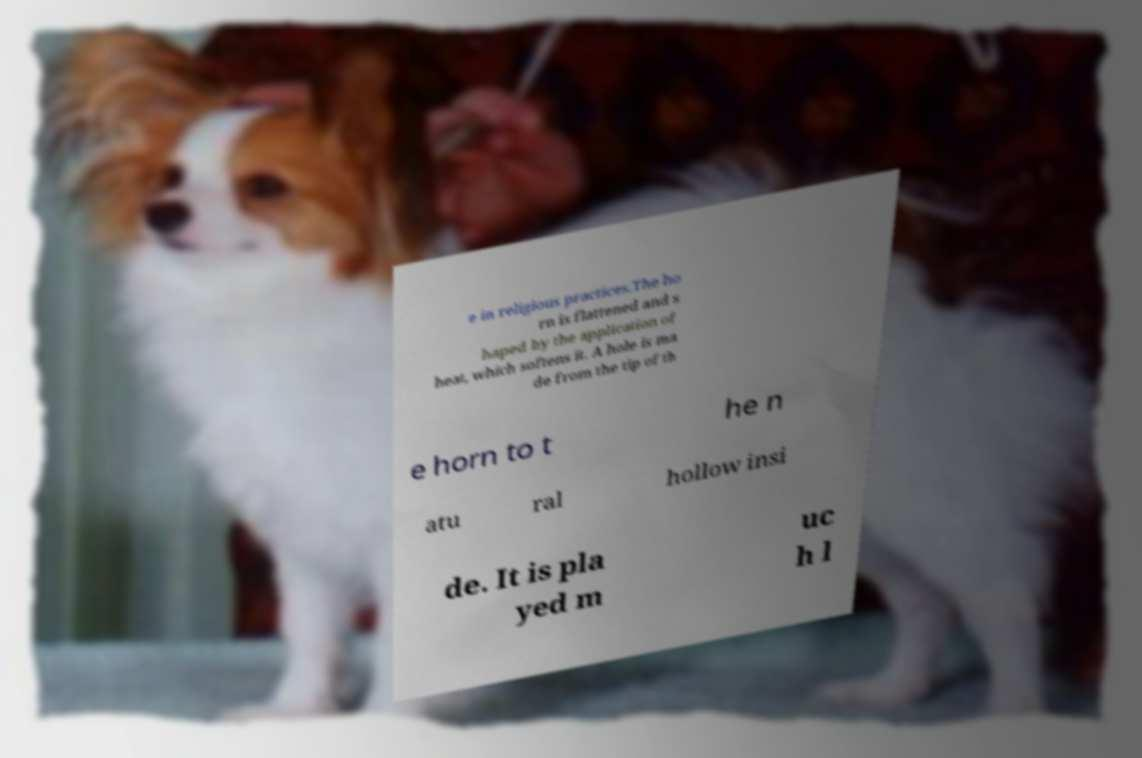Please read and relay the text visible in this image. What does it say? e in religious practices.The ho rn is flattened and s haped by the application of heat, which softens it. A hole is ma de from the tip of th e horn to t he n atu ral hollow insi de. It is pla yed m uc h l 